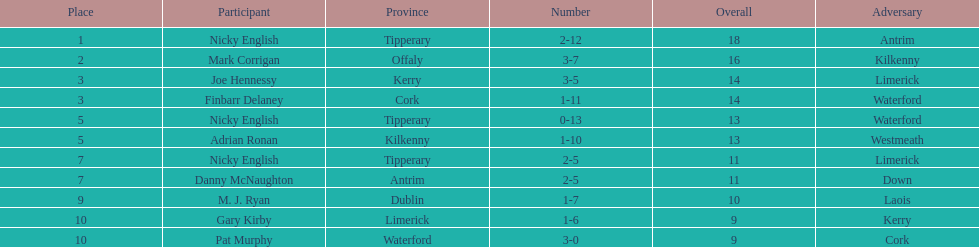Who ranked above mark corrigan? Nicky English. 